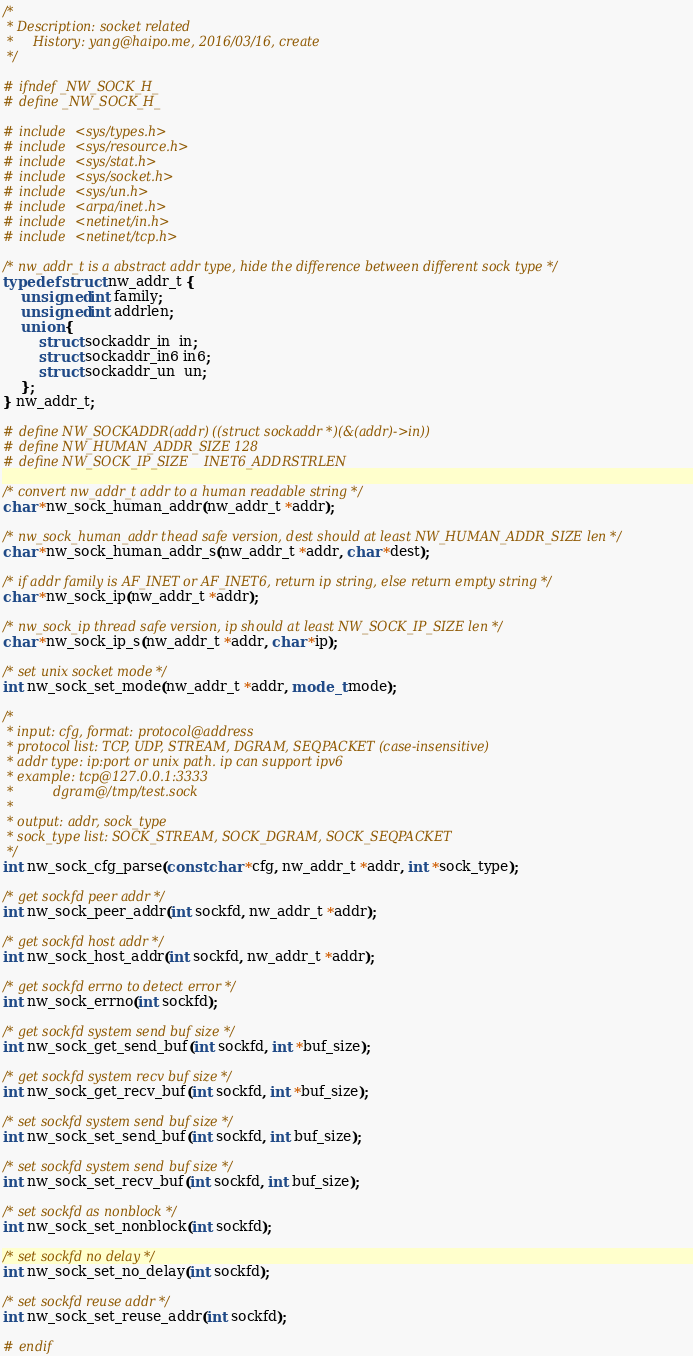<code> <loc_0><loc_0><loc_500><loc_500><_C_>/*
 * Description: socket related
 *     History: yang@haipo.me, 2016/03/16, create
 */

# ifndef _NW_SOCK_H_
# define _NW_SOCK_H_

# include <sys/types.h>
# include <sys/resource.h>
# include <sys/stat.h>
# include <sys/socket.h>
# include <sys/un.h>
# include <arpa/inet.h>
# include <netinet/in.h>
# include <netinet/tcp.h>

/* nw_addr_t is a abstract addr type, hide the difference between different sock type */
typedef struct nw_addr_t {
    unsigned int family;
    unsigned int addrlen;
    union {
        struct sockaddr_in  in;
        struct sockaddr_in6 in6;
        struct sockaddr_un  un;
    };
} nw_addr_t;

# define NW_SOCKADDR(addr) ((struct sockaddr *)(&(addr)->in))
# define NW_HUMAN_ADDR_SIZE 128
# define NW_SOCK_IP_SIZE    INET6_ADDRSTRLEN

/* convert nw_addr_t addr to a human readable string */
char *nw_sock_human_addr(nw_addr_t *addr);

/* nw_sock_human_addr thead safe version, dest should at least NW_HUMAN_ADDR_SIZE len */
char *nw_sock_human_addr_s(nw_addr_t *addr, char *dest);

/* if addr family is AF_INET or AF_INET6, return ip string, else return empty string */
char *nw_sock_ip(nw_addr_t *addr);

/* nw_sock_ip thread safe version, ip should at least NW_SOCK_IP_SIZE len */
char *nw_sock_ip_s(nw_addr_t *addr, char *ip);

/* set unix socket mode */
int nw_sock_set_mode(nw_addr_t *addr, mode_t mode);

/*
 * input: cfg, format: protocol@address
 * protocol list: TCP, UDP, STREAM, DGRAM, SEQPACKET (case-insensitive)
 * addr type: ip:port or unix path. ip can support ipv6
 * example: tcp@127.0.0.1:3333
 *          dgram@/tmp/test.sock
 *
 * output: addr, sock_type
 * sock_type list: SOCK_STREAM, SOCK_DGRAM, SOCK_SEQPACKET
 */
int nw_sock_cfg_parse(const char *cfg, nw_addr_t *addr, int *sock_type);

/* get sockfd peer addr */
int nw_sock_peer_addr(int sockfd, nw_addr_t *addr);

/* get sockfd host addr */
int nw_sock_host_addr(int sockfd, nw_addr_t *addr);

/* get sockfd errno to detect error */
int nw_sock_errno(int sockfd);

/* get sockfd system send buf size */
int nw_sock_get_send_buf(int sockfd, int *buf_size);

/* get sockfd system recv buf size */
int nw_sock_get_recv_buf(int sockfd, int *buf_size);

/* set sockfd system send buf size */
int nw_sock_set_send_buf(int sockfd, int buf_size);

/* set sockfd system send buf size */
int nw_sock_set_recv_buf(int sockfd, int buf_size);

/* set sockfd as nonblock */
int nw_sock_set_nonblock(int sockfd);

/* set sockfd no delay */
int nw_sock_set_no_delay(int sockfd);

/* set sockfd reuse addr */
int nw_sock_set_reuse_addr(int sockfd);

# endif

</code> 